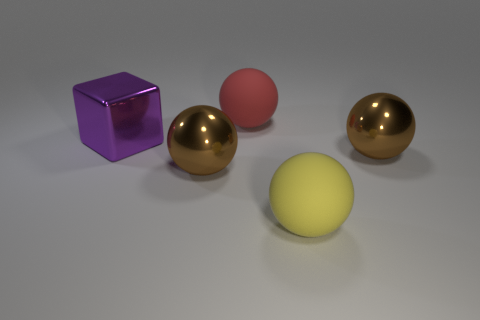Subtract 1 balls. How many balls are left? 3 Subtract all purple spheres. Subtract all cyan cylinders. How many spheres are left? 4 Add 4 large brown objects. How many objects exist? 9 Subtract all cubes. How many objects are left? 4 Add 3 red spheres. How many red spheres are left? 4 Add 5 big brown shiny spheres. How many big brown shiny spheres exist? 7 Subtract 0 blue spheres. How many objects are left? 5 Subtract all purple metal cubes. Subtract all brown spheres. How many objects are left? 2 